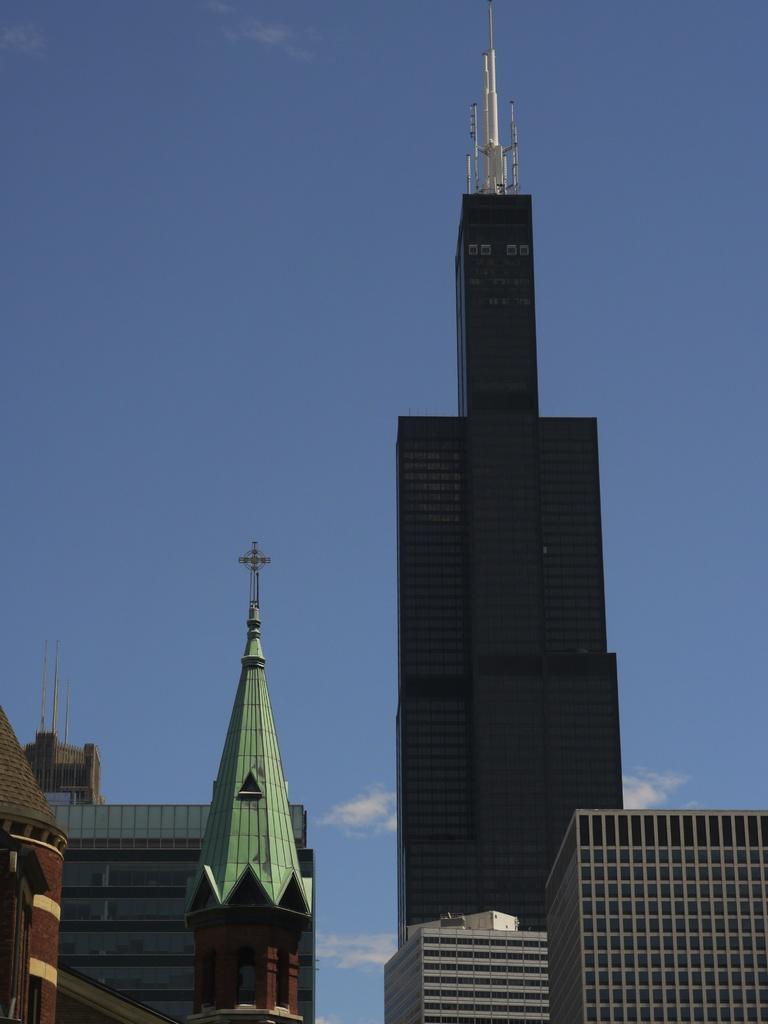Describe this image in one or two sentences. In this image we can see many buildings. On top of the building there is a tower. On another building there is a cross on the top. In the background there is sky with clouds. 